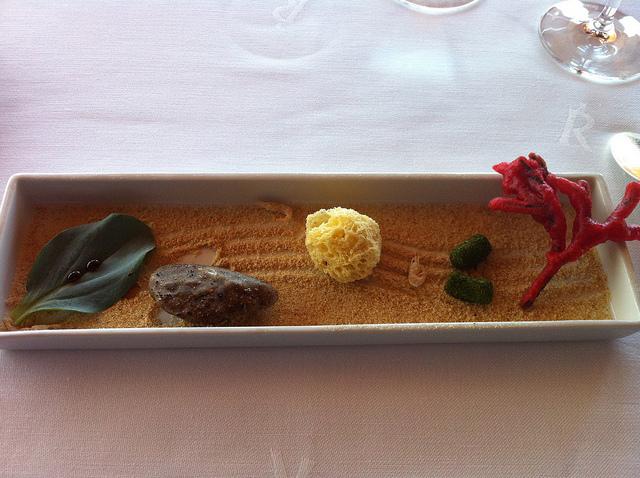What shape is the plate?
Quick response, please. Rectangle. What color is the sheets?
Write a very short answer. White. Is there a leaf?
Be succinct. Yes. 